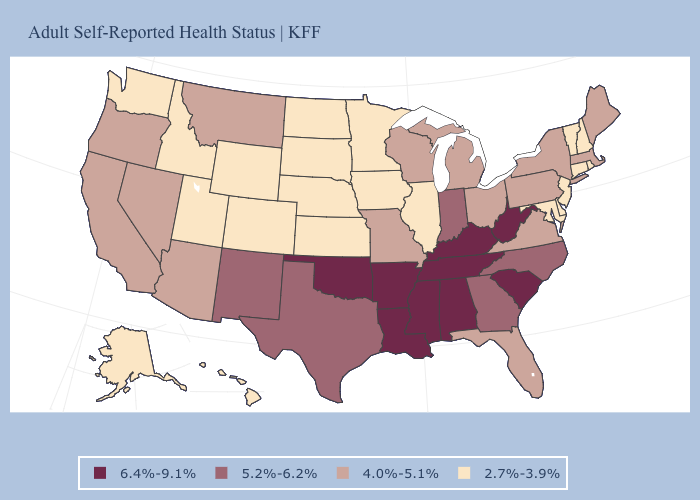How many symbols are there in the legend?
Concise answer only. 4. Name the states that have a value in the range 2.7%-3.9%?
Be succinct. Alaska, Colorado, Connecticut, Delaware, Hawaii, Idaho, Illinois, Iowa, Kansas, Maryland, Minnesota, Nebraska, New Hampshire, New Jersey, North Dakota, Rhode Island, South Dakota, Utah, Vermont, Washington, Wyoming. Name the states that have a value in the range 4.0%-5.1%?
Keep it brief. Arizona, California, Florida, Maine, Massachusetts, Michigan, Missouri, Montana, Nevada, New York, Ohio, Oregon, Pennsylvania, Virginia, Wisconsin. Does West Virginia have the highest value in the USA?
Answer briefly. Yes. What is the value of California?
Short answer required. 4.0%-5.1%. What is the value of Texas?
Give a very brief answer. 5.2%-6.2%. What is the lowest value in states that border Idaho?
Short answer required. 2.7%-3.9%. Does New Jersey have the lowest value in the Northeast?
Give a very brief answer. Yes. Among the states that border Utah , which have the lowest value?
Be succinct. Colorado, Idaho, Wyoming. What is the value of Oregon?
Keep it brief. 4.0%-5.1%. Among the states that border Georgia , which have the lowest value?
Quick response, please. Florida. Among the states that border South Dakota , does Iowa have the lowest value?
Write a very short answer. Yes. Among the states that border New Mexico , does Utah have the lowest value?
Keep it brief. Yes. Does New Mexico have the highest value in the West?
Keep it brief. Yes. 